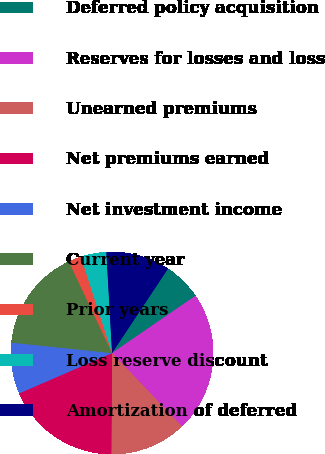<chart> <loc_0><loc_0><loc_500><loc_500><pie_chart><fcel>(In thousands)<fcel>Deferred policy acquisition<fcel>Reserves for losses and loss<fcel>Unearned premiums<fcel>Net premiums earned<fcel>Net investment income<fcel>Current year<fcel>Prior years<fcel>Loss reserve discount<fcel>Amortization of deferred<nl><fcel>0.0%<fcel>6.12%<fcel>22.44%<fcel>12.24%<fcel>18.36%<fcel>8.16%<fcel>16.32%<fcel>2.04%<fcel>4.08%<fcel>10.2%<nl></chart> 